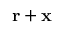Convert formula to latex. <formula><loc_0><loc_0><loc_500><loc_500>r + x</formula> 